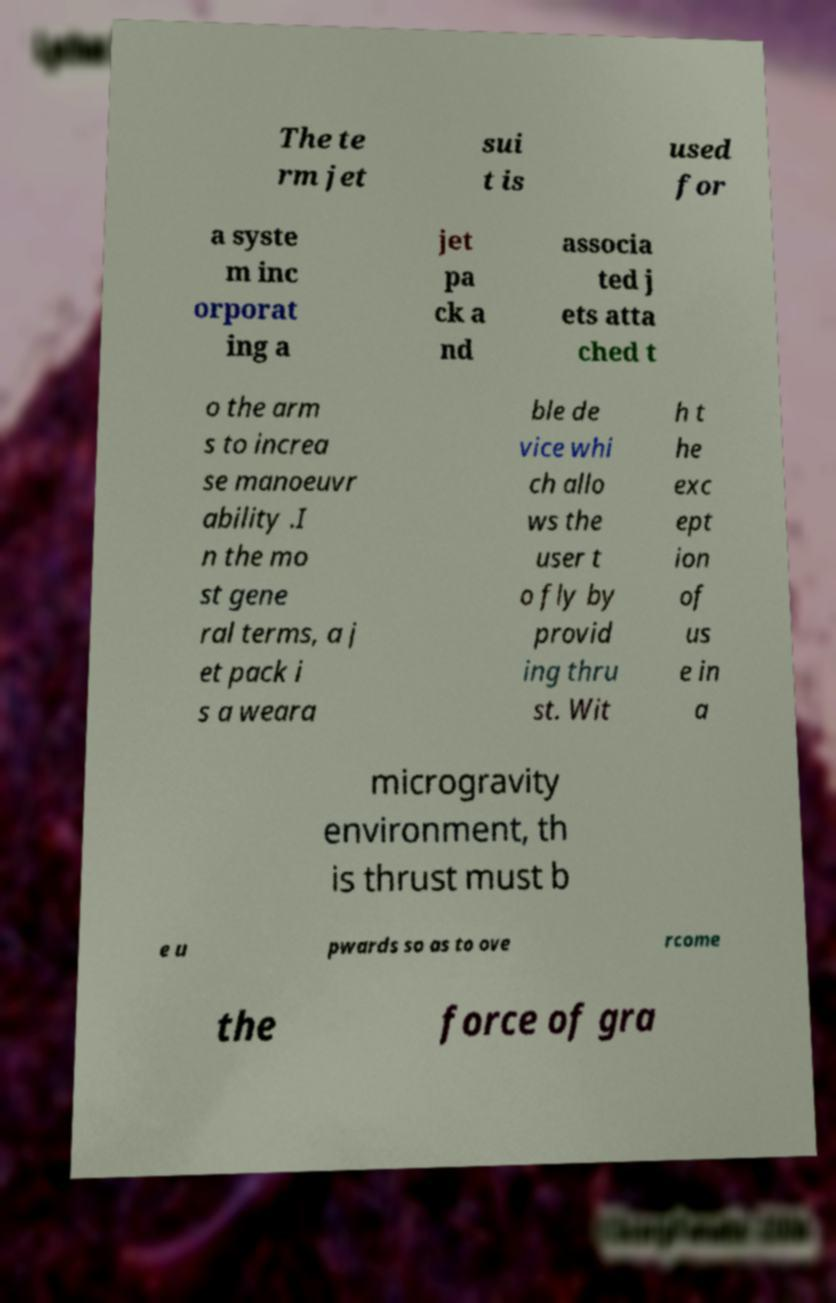I need the written content from this picture converted into text. Can you do that? The te rm jet sui t is used for a syste m inc orporat ing a jet pa ck a nd associa ted j ets atta ched t o the arm s to increa se manoeuvr ability .I n the mo st gene ral terms, a j et pack i s a weara ble de vice whi ch allo ws the user t o fly by provid ing thru st. Wit h t he exc ept ion of us e in a microgravity environment, th is thrust must b e u pwards so as to ove rcome the force of gra 